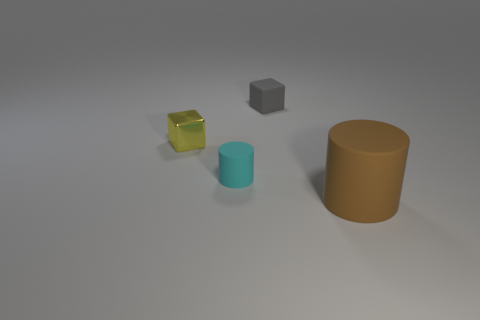There is a yellow shiny thing that is the same shape as the tiny gray rubber object; what size is it?
Your answer should be very brief. Small. What number of tiny things are brown rubber things or balls?
Your answer should be compact. 0. What size is the yellow object?
Provide a short and direct response. Small. The yellow thing is what shape?
Provide a short and direct response. Cube. Are there fewer brown things that are behind the small gray object than tiny gray cubes?
Provide a succinct answer. Yes. How many metal things are either small green things or big brown things?
Provide a short and direct response. 0. Is there any other thing that has the same size as the brown rubber object?
Ensure brevity in your answer.  No. What color is the small cylinder that is made of the same material as the tiny gray cube?
Provide a succinct answer. Cyan. How many cubes are either small yellow metal things or cyan rubber things?
Offer a terse response. 1. How many objects are either large rubber objects or tiny objects in front of the yellow metal block?
Provide a short and direct response. 2. 